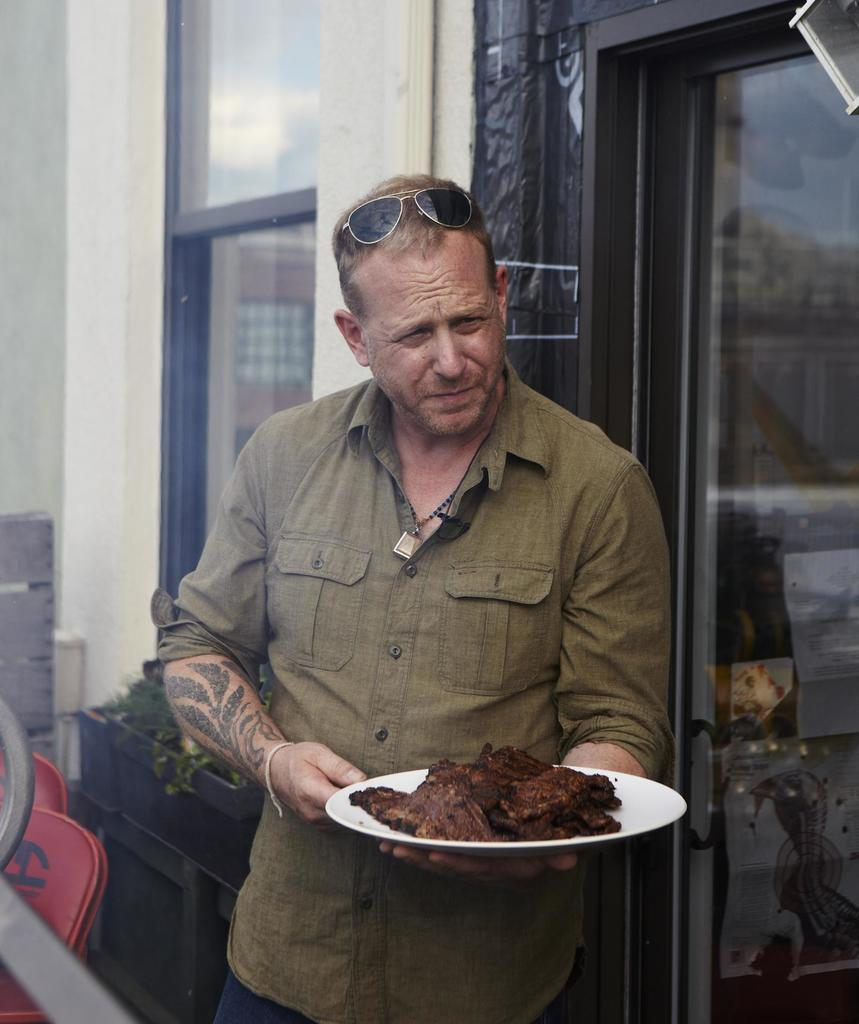What is the person in the image holding? The person is holding food on a plate in the image. What color are the objects in the image? There are red objects in the image. What type of objects are in black? There are items in black objects in the image. What can be seen in the distance in the image? There is a building in the background of the image. Is there a toothbrush visible in the image? There is no toothbrush present in the image. What type of event is being celebrated in the image? The image does not depict a specific event or celebration. 